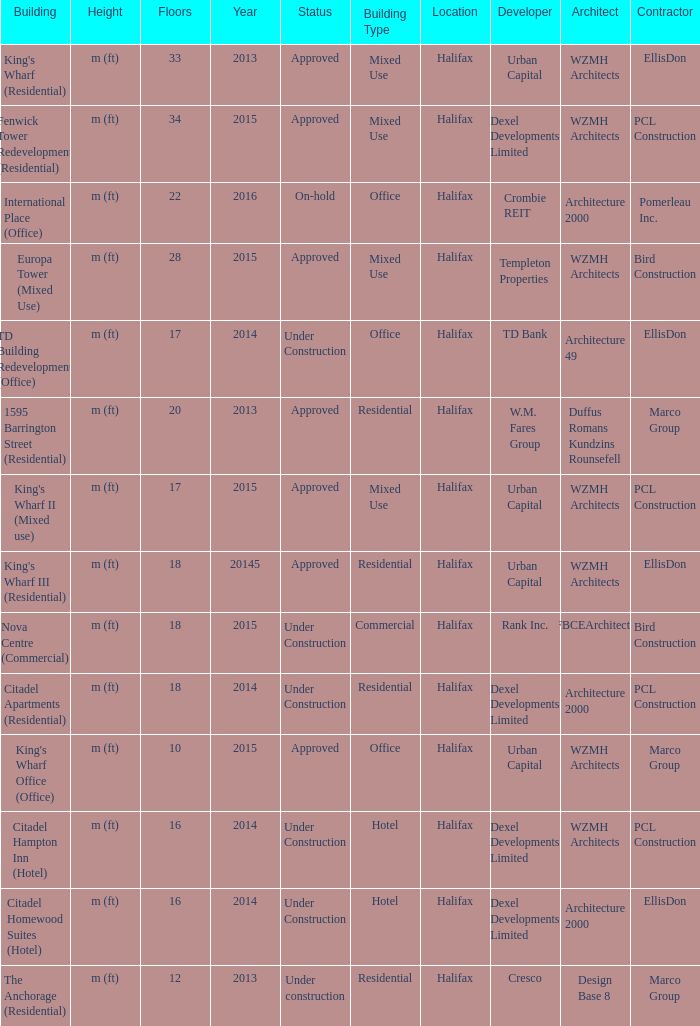What are the number of floors for the building of td building redevelopment (office)? 17.0. 